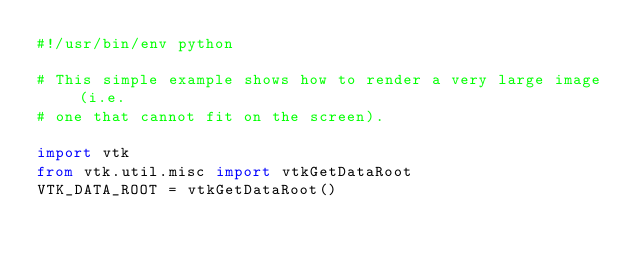<code> <loc_0><loc_0><loc_500><loc_500><_Python_>#!/usr/bin/env python

# This simple example shows how to render a very large image (i.e.
# one that cannot fit on the screen).

import vtk
from vtk.util.misc import vtkGetDataRoot
VTK_DATA_ROOT = vtkGetDataRoot()
</code> 